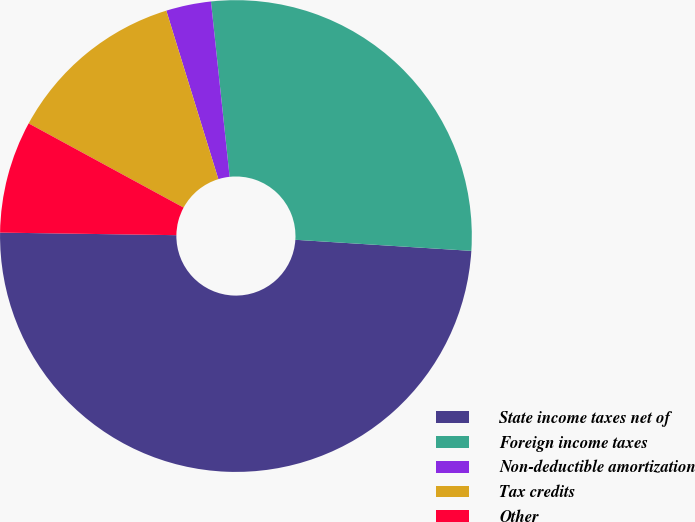Convert chart to OTSL. <chart><loc_0><loc_0><loc_500><loc_500><pie_chart><fcel>State income taxes net of<fcel>Foreign income taxes<fcel>Non-deductible amortization<fcel>Tax credits<fcel>Other<nl><fcel>49.23%<fcel>27.69%<fcel>3.08%<fcel>12.31%<fcel>7.69%<nl></chart> 